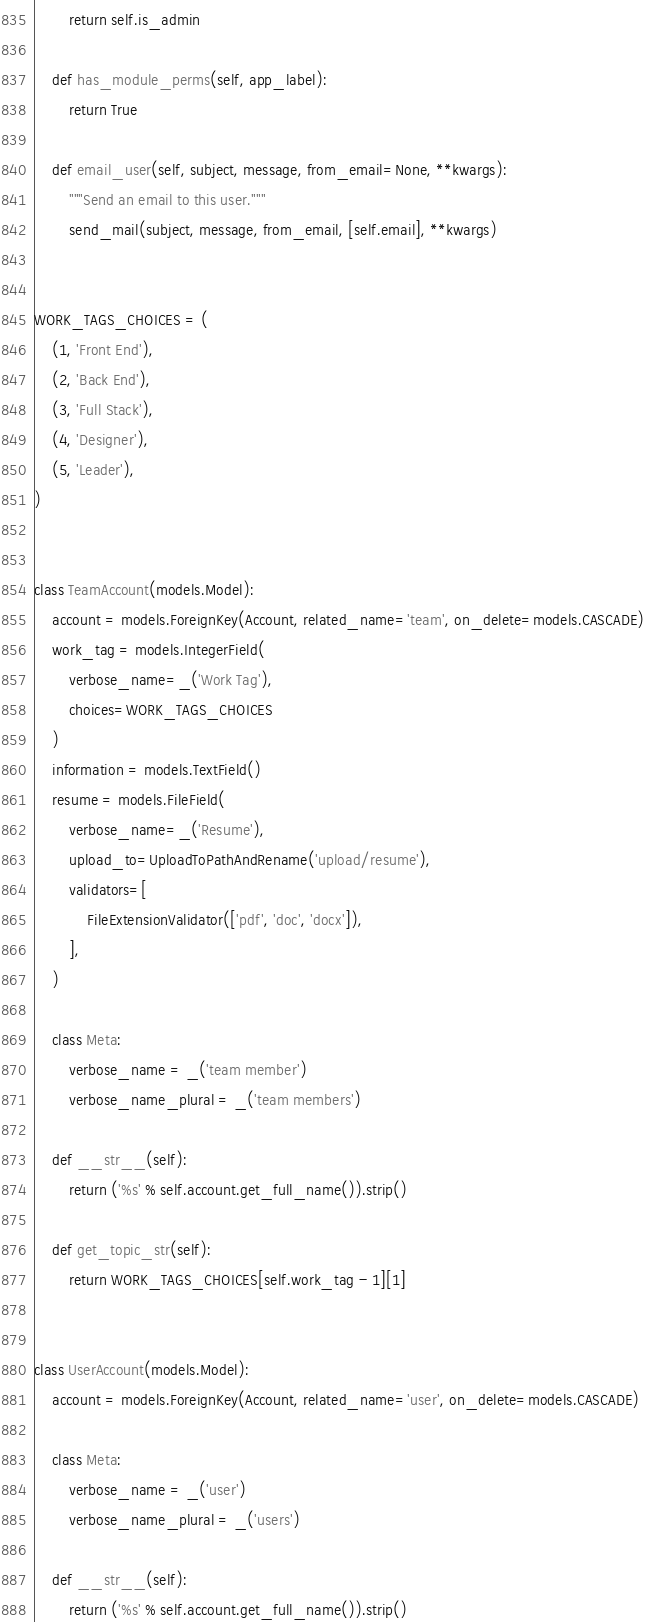Convert code to text. <code><loc_0><loc_0><loc_500><loc_500><_Python_>        return self.is_admin

    def has_module_perms(self, app_label):
        return True

    def email_user(self, subject, message, from_email=None, **kwargs):
        """Send an email to this user."""
        send_mail(subject, message, from_email, [self.email], **kwargs)


WORK_TAGS_CHOICES = (
    (1, 'Front End'),
    (2, 'Back End'),
    (3, 'Full Stack'),
    (4, 'Designer'),
    (5, 'Leader'),
)


class TeamAccount(models.Model):
    account = models.ForeignKey(Account, related_name='team', on_delete=models.CASCADE)
    work_tag = models.IntegerField(
        verbose_name=_('Work Tag'),
        choices=WORK_TAGS_CHOICES
    )
    information = models.TextField()
    resume = models.FileField(
        verbose_name=_('Resume'),
        upload_to=UploadToPathAndRename('upload/resume'),
        validators=[
            FileExtensionValidator(['pdf', 'doc', 'docx']),
        ],
    )

    class Meta:
        verbose_name = _('team member')
        verbose_name_plural = _('team members')

    def __str__(self):
        return ('%s' % self.account.get_full_name()).strip()

    def get_topic_str(self):
        return WORK_TAGS_CHOICES[self.work_tag - 1][1]


class UserAccount(models.Model):
    account = models.ForeignKey(Account, related_name='user', on_delete=models.CASCADE)

    class Meta:
        verbose_name = _('user')
        verbose_name_plural = _('users')

    def __str__(self):
        return ('%s' % self.account.get_full_name()).strip()
</code> 